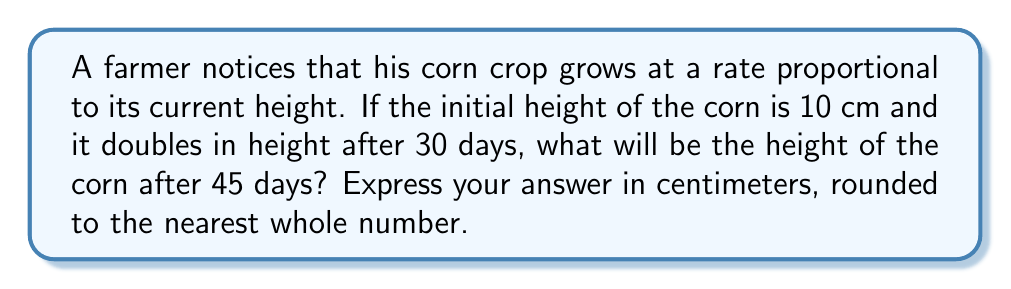Can you answer this question? Let's approach this step-by-step using differential equations:

1) Let $h(t)$ be the height of the corn at time $t$ (in days).

2) The growth rate is proportional to the current height, so we can write:

   $$\frac{dh}{dt} = kh$$

   where $k$ is the growth constant.

3) This is a separable differential equation. Solving it:

   $$\int \frac{dh}{h} = \int k dt$$
   $$\ln|h| = kt + C$$
   $$h(t) = Ae^{kt}$$

   where $A$ is a constant.

4) Using the initial condition $h(0) = 10$, we find $A = 10$. So:

   $$h(t) = 10e^{kt}$$

5) We're told the height doubles after 30 days. This means:

   $$20 = 10e^{30k}$$
   $$2 = e^{30k}$$
   $$\ln 2 = 30k$$
   $$k = \frac{\ln 2}{30}$$

6) Now we have the complete equation:

   $$h(t) = 10e^{(\ln 2 / 30)t}$$

7) To find the height after 45 days, we plug in $t = 45$:

   $$h(45) = 10e^{(\ln 2 / 30) * 45}$$
   $$= 10e^{1.5 \ln 2}$$
   $$= 10 * 2^{1.5}$$
   $$\approx 28.28$$

8) Rounding to the nearest whole number, we get 28 cm.
Answer: 28 cm 